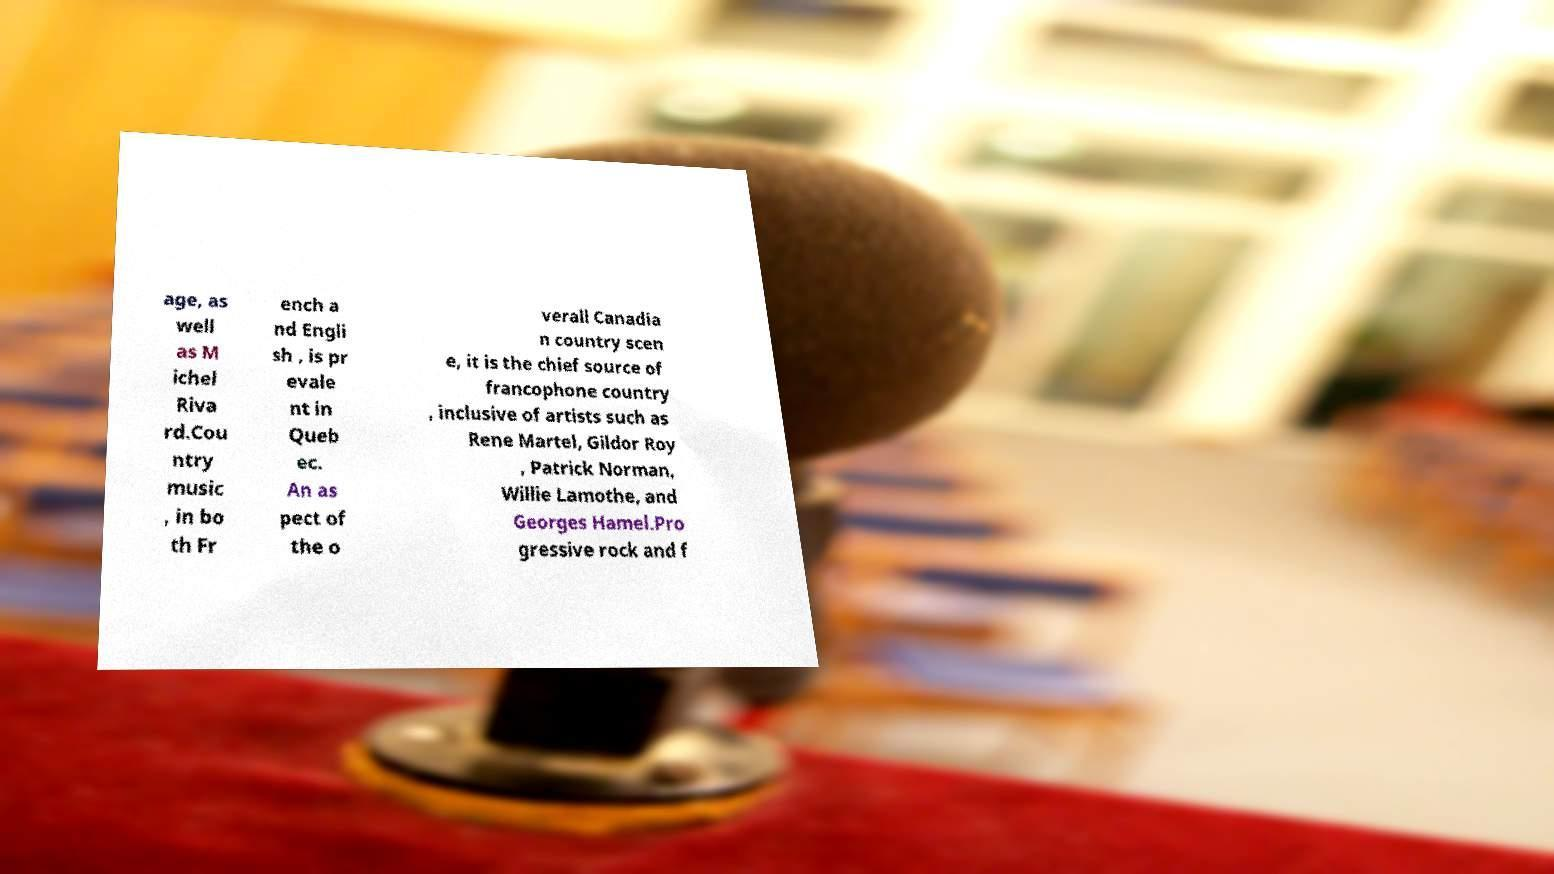Could you extract and type out the text from this image? age, as well as M ichel Riva rd.Cou ntry music , in bo th Fr ench a nd Engli sh , is pr evale nt in Queb ec. An as pect of the o verall Canadia n country scen e, it is the chief source of francophone country , inclusive of artists such as Rene Martel, Gildor Roy , Patrick Norman, Willie Lamothe, and Georges Hamel.Pro gressive rock and f 